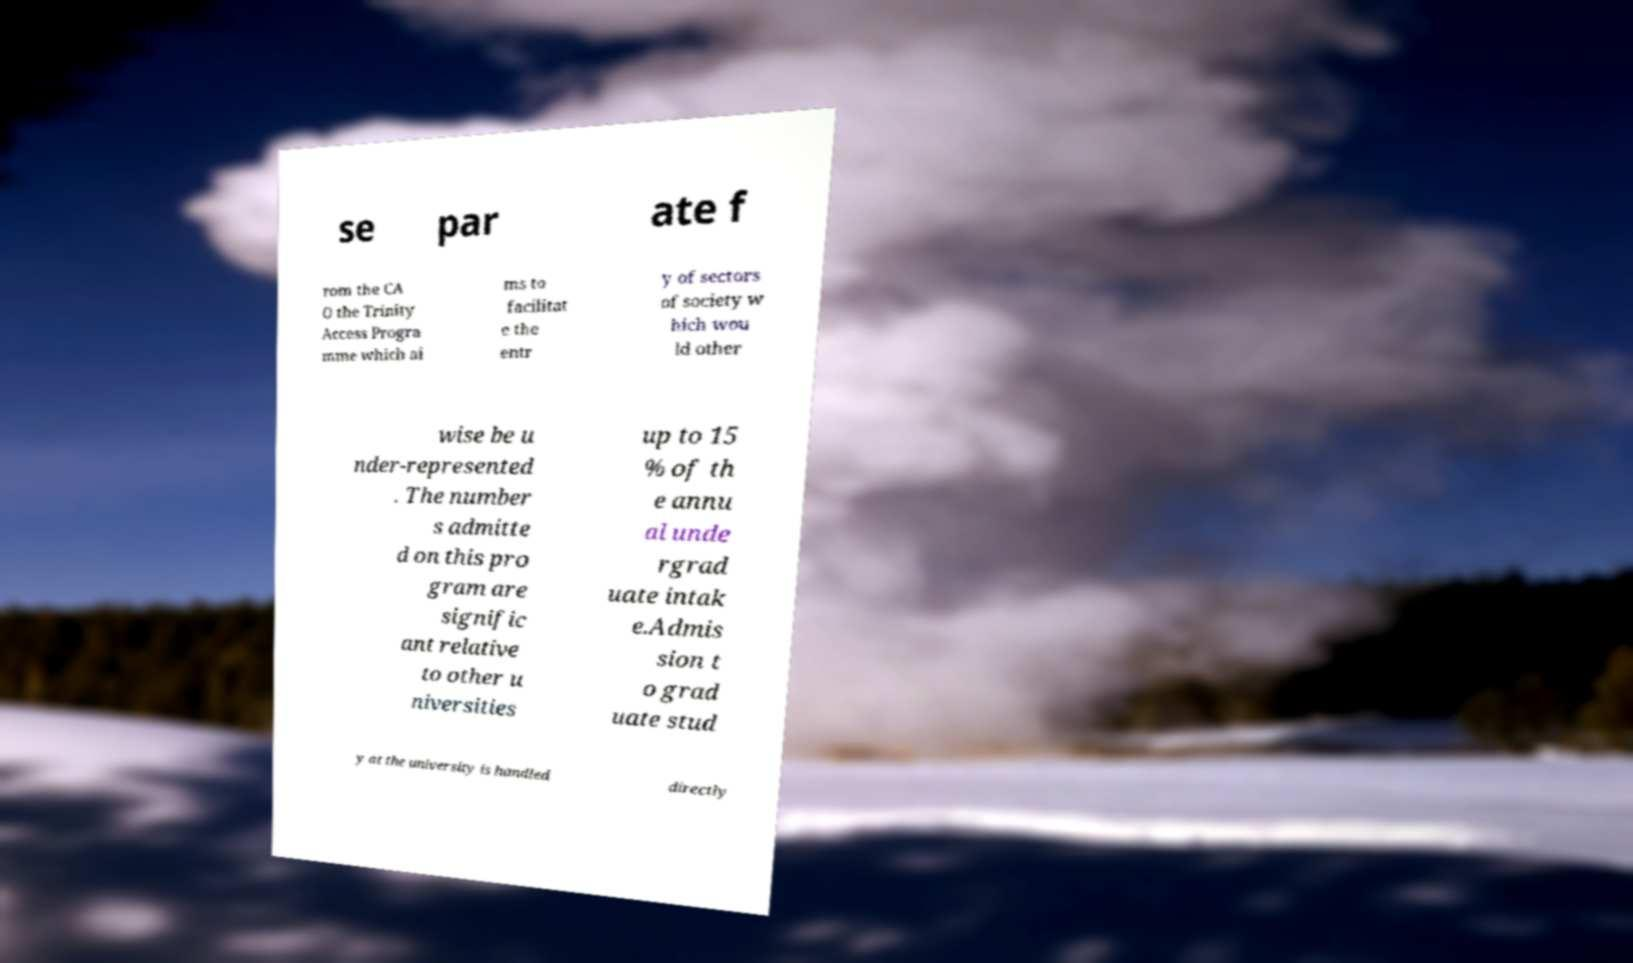What messages or text are displayed in this image? I need them in a readable, typed format. se par ate f rom the CA O the Trinity Access Progra mme which ai ms to facilitat e the entr y of sectors of society w hich wou ld other wise be u nder-represented . The number s admitte d on this pro gram are signific ant relative to other u niversities up to 15 % of th e annu al unde rgrad uate intak e.Admis sion t o grad uate stud y at the university is handled directly 